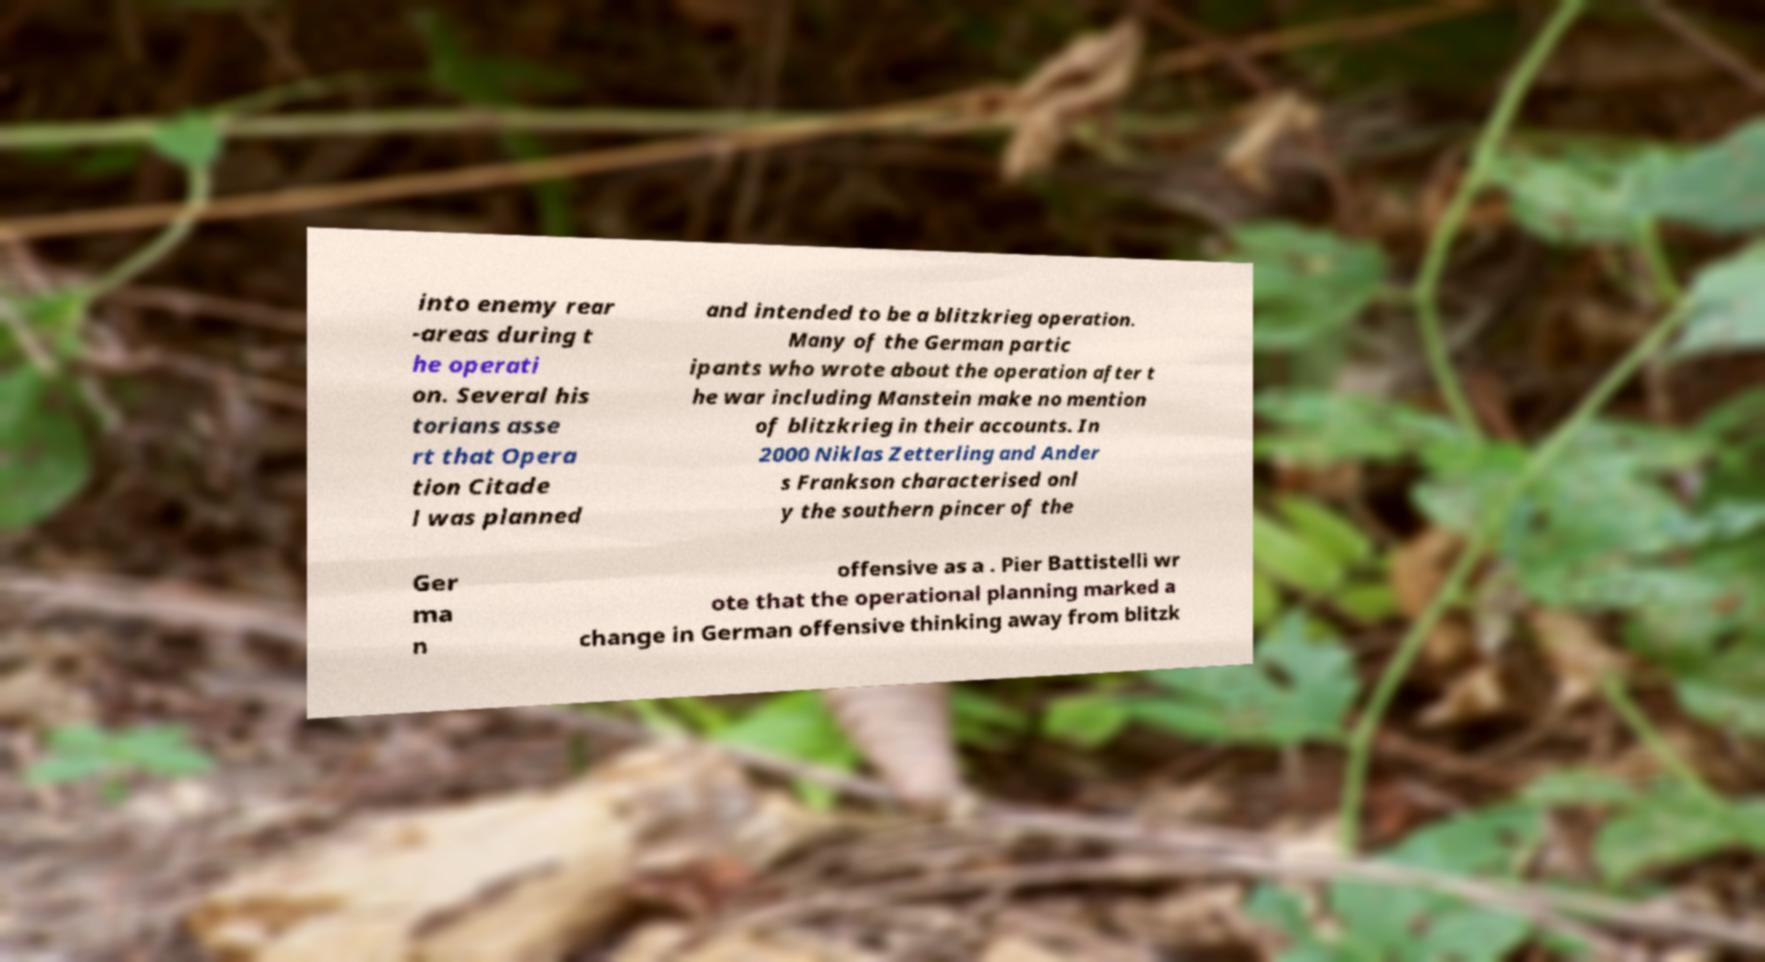What messages or text are displayed in this image? I need them in a readable, typed format. into enemy rear -areas during t he operati on. Several his torians asse rt that Opera tion Citade l was planned and intended to be a blitzkrieg operation. Many of the German partic ipants who wrote about the operation after t he war including Manstein make no mention of blitzkrieg in their accounts. In 2000 Niklas Zetterling and Ander s Frankson characterised onl y the southern pincer of the Ger ma n offensive as a . Pier Battistelli wr ote that the operational planning marked a change in German offensive thinking away from blitzk 